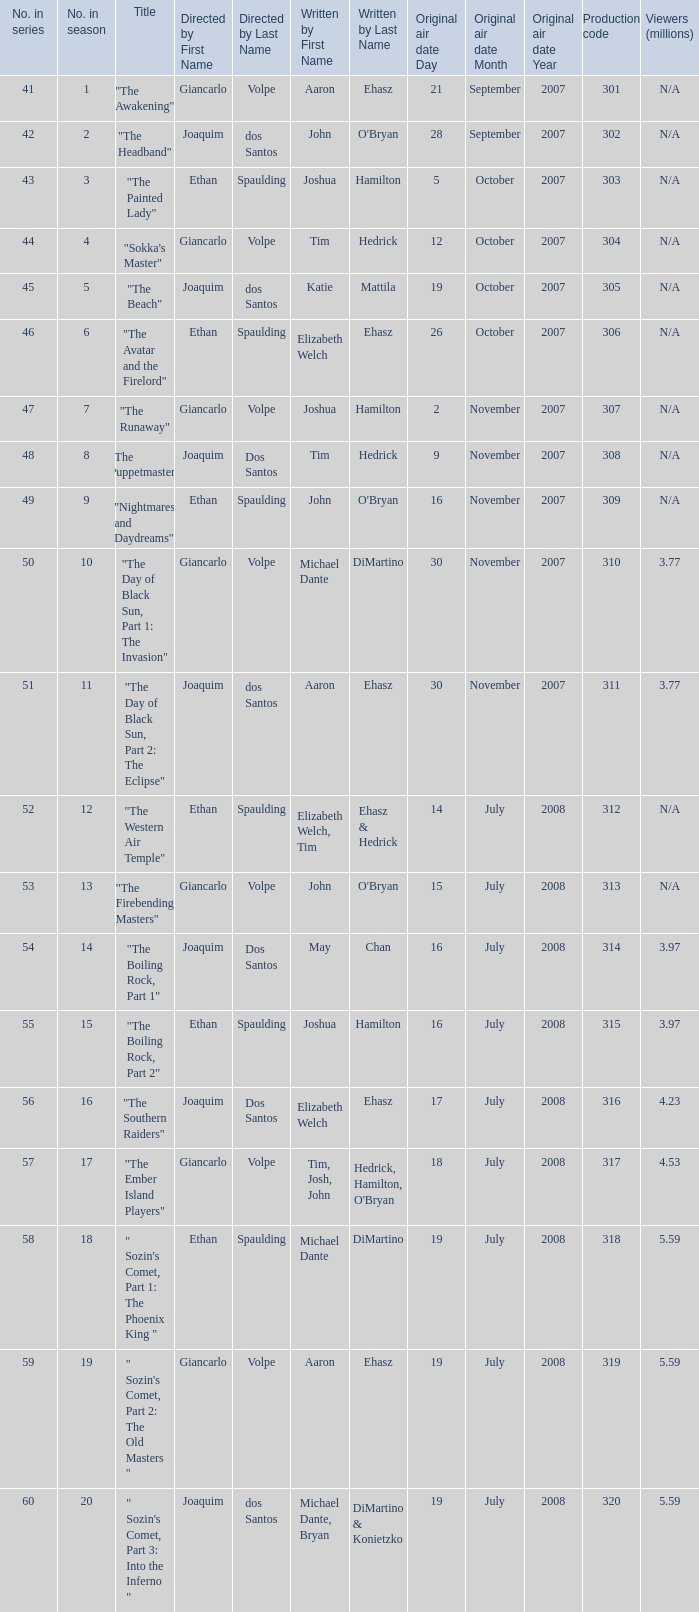What are all the numbers in the series with an episode title of "the beach"? 45.0. 